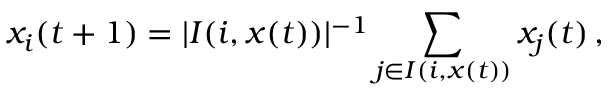<formula> <loc_0><loc_0><loc_500><loc_500>x _ { i } ( t + 1 ) = | I ( i , x ( t ) ) | ^ { - 1 } \sum _ { j \in I ( i , x ( t ) ) } x _ { j } ( t ) \, ,</formula> 